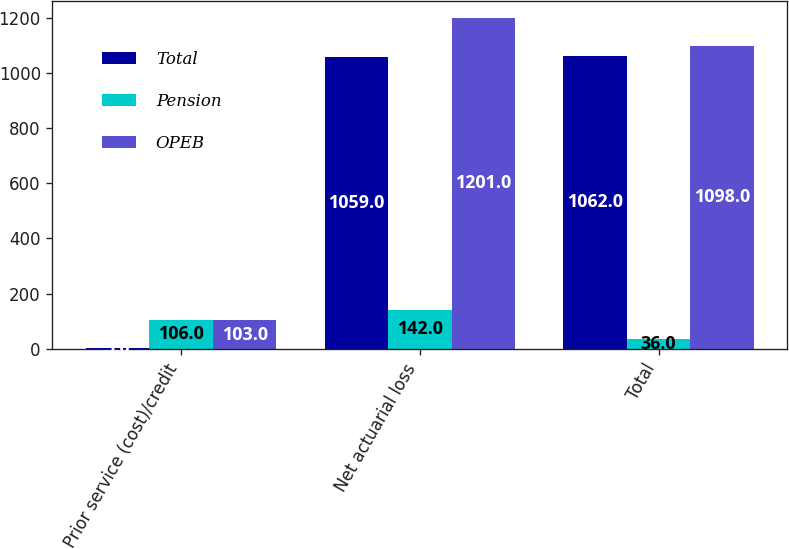Convert chart. <chart><loc_0><loc_0><loc_500><loc_500><stacked_bar_chart><ecel><fcel>Prior service (cost)/credit<fcel>Net actuarial loss<fcel>Total<nl><fcel>Total<fcel>3<fcel>1059<fcel>1062<nl><fcel>Pension<fcel>106<fcel>142<fcel>36<nl><fcel>OPEB<fcel>103<fcel>1201<fcel>1098<nl></chart> 